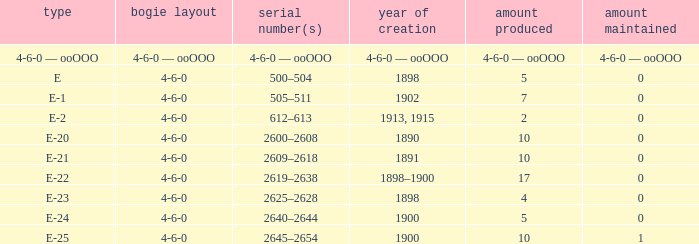What is the quantity made of the e-22 class, which has a quantity preserved of 0? 17.0. Parse the full table. {'header': ['type', 'bogie layout', 'serial number(s)', 'year of creation', 'amount produced', 'amount maintained'], 'rows': [['4-6-0 — ooOOO', '4-6-0 — ooOOO', '4-6-0 — ooOOO', '4-6-0 — ooOOO', '4-6-0 — ooOOO', '4-6-0 — ooOOO'], ['E', '4-6-0', '500–504', '1898', '5', '0'], ['E-1', '4-6-0', '505–511', '1902', '7', '0'], ['E-2', '4-6-0', '612–613', '1913, 1915', '2', '0'], ['E-20', '4-6-0', '2600–2608', '1890', '10', '0'], ['E-21', '4-6-0', '2609–2618', '1891', '10', '0'], ['E-22', '4-6-0', '2619–2638', '1898–1900', '17', '0'], ['E-23', '4-6-0', '2625–2628', '1898', '4', '0'], ['E-24', '4-6-0', '2640–2644', '1900', '5', '0'], ['E-25', '4-6-0', '2645–2654', '1900', '10', '1']]} 